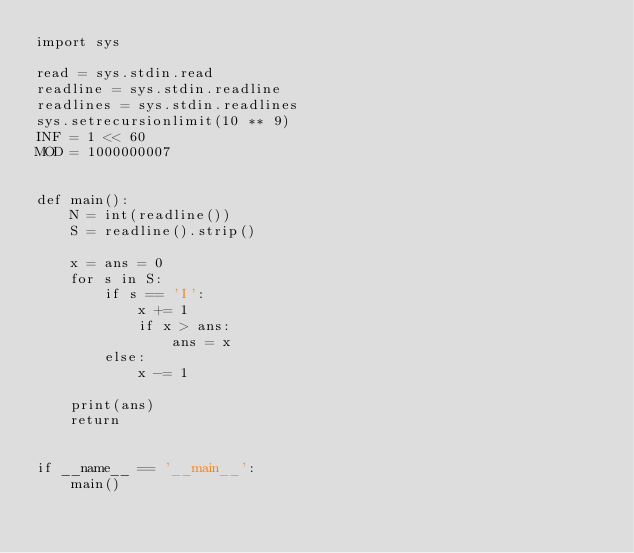Convert code to text. <code><loc_0><loc_0><loc_500><loc_500><_Python_>import sys

read = sys.stdin.read
readline = sys.stdin.readline
readlines = sys.stdin.readlines
sys.setrecursionlimit(10 ** 9)
INF = 1 << 60
MOD = 1000000007


def main():
    N = int(readline())
    S = readline().strip()

    x = ans = 0
    for s in S:
        if s == 'I':
            x += 1
            if x > ans:
                ans = x
        else:
            x -= 1

    print(ans)
    return


if __name__ == '__main__':
    main()
</code> 